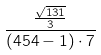Convert formula to latex. <formula><loc_0><loc_0><loc_500><loc_500>\frac { \frac { \sqrt { 1 3 1 } } { 3 } } { ( 4 5 4 - 1 ) \cdot 7 }</formula> 